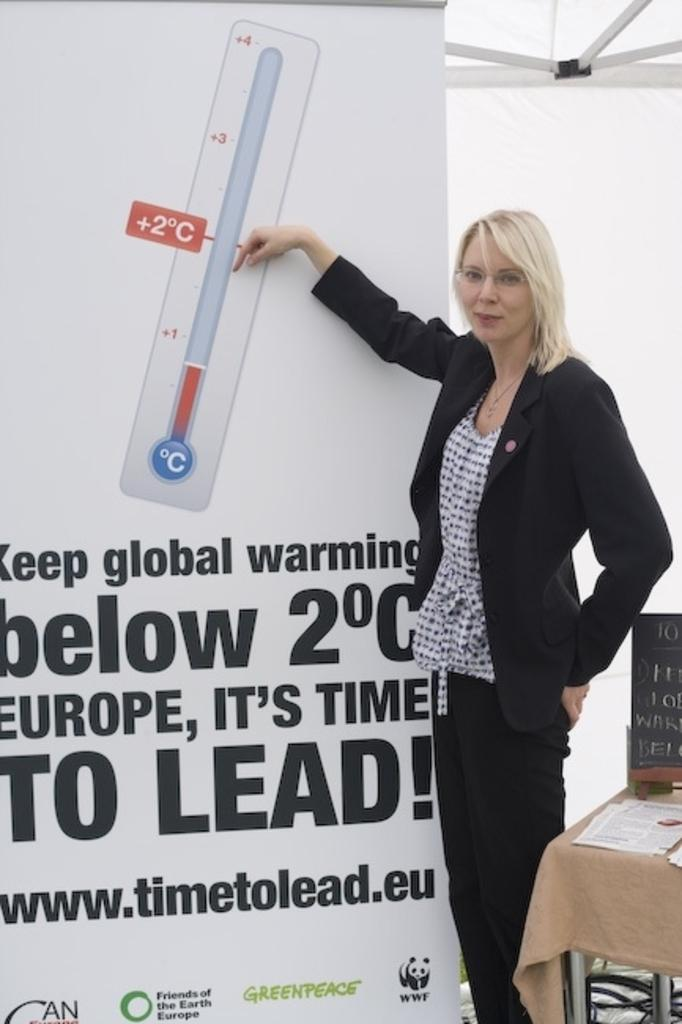Who is present in the image? There is a woman in the image. What is the woman doing in the image? The woman is standing and smiling in the image. What is the woman holding in the image? The woman is holding a hoarding in the image. What can be seen in the background of the image? There is a tent, a table, papers, and a board in the background of the image. What type of linen is being used to cover the table in the image? There is no linen visible in the image; the table is not covered. 